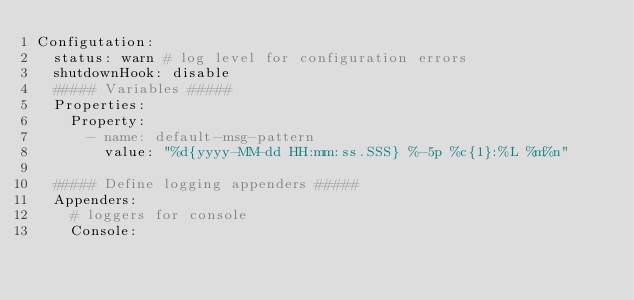<code> <loc_0><loc_0><loc_500><loc_500><_YAML_>Configutation:
  status: warn # log level for configuration errors
  shutdownHook: disable
  ##### Variables #####
  Properties:
    Property:
      - name: default-msg-pattern
        value: "%d{yyyy-MM-dd HH:mm:ss.SSS} %-5p %c{1}:%L %m%n"

  ##### Define logging appenders #####
  Appenders:
    # loggers for console
    Console:</code> 